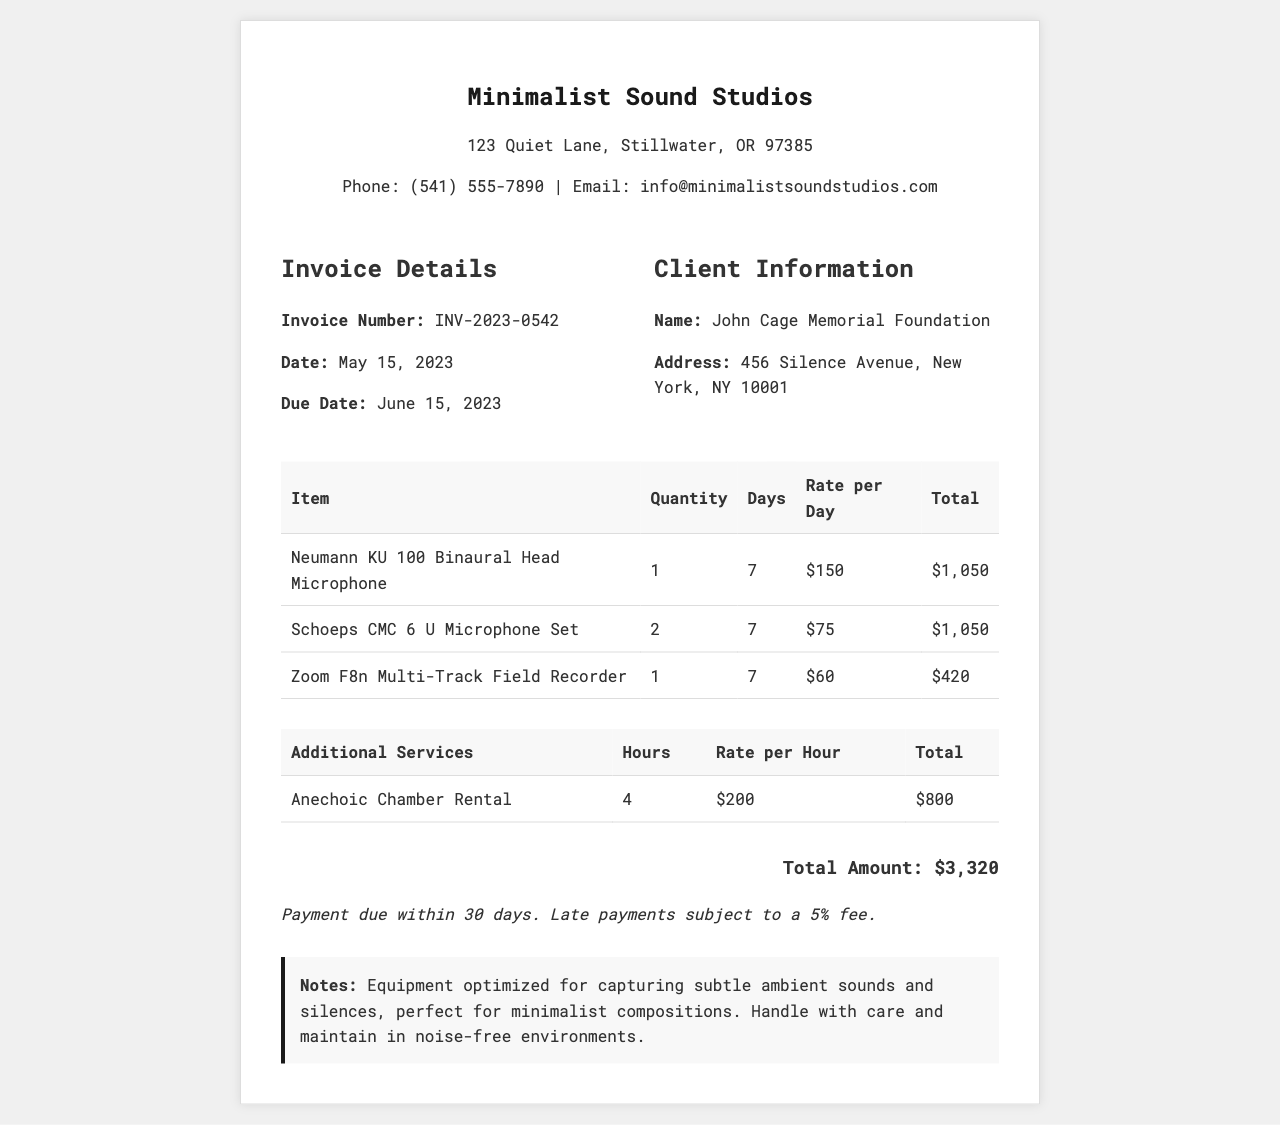What is the invoice number? The invoice number is detailed in the document under "Invoice Details" as INV-2023-0542.
Answer: INV-2023-0542 Who is the client? The client's name is specified in the "Client Information" section, which lists John Cage Memorial Foundation.
Answer: John Cage Memorial Foundation What is the total amount due? The total amount is provided at the end of the document, summing all charges, which is $3,320.
Answer: $3,320 How many days was the Neumann KU 100 Binaural Head Microphone rented? The document states that the Neumann KU 100 Binaural Head Microphone was rented for 7 days.
Answer: 7 What is the rental rate for the Anechoic Chamber per hour? The rate for the Anechoic Chamber is listed in the additional services section as $200 per hour.
Answer: $200 What additional service was included in the invoice? The invoice includes the service of Anechoic Chamber Rental as the sole additional service.
Answer: Anechoic Chamber Rental What is the due date for payment? The due date is mentioned under "Invoice Details," which is June 15, 2023.
Answer: June 15, 2023 How many Schoeps CMC 6 U Microphone Sets were rented? The document indicates that 2 Schoeps CMC 6 U Microphone Sets were rented.
Answer: 2 What is the payment term for late payments? The payment term states that late payments are subject to a 5% fee.
Answer: 5% fee 